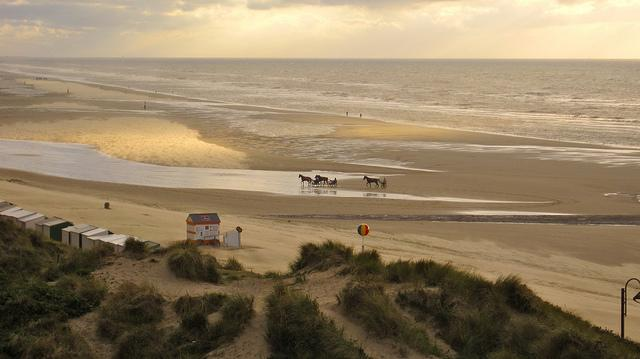What are the horses doing? Please explain your reasoning. pulling sleds. The horses are on the beach. the people near them appear to be in wetsuits. 